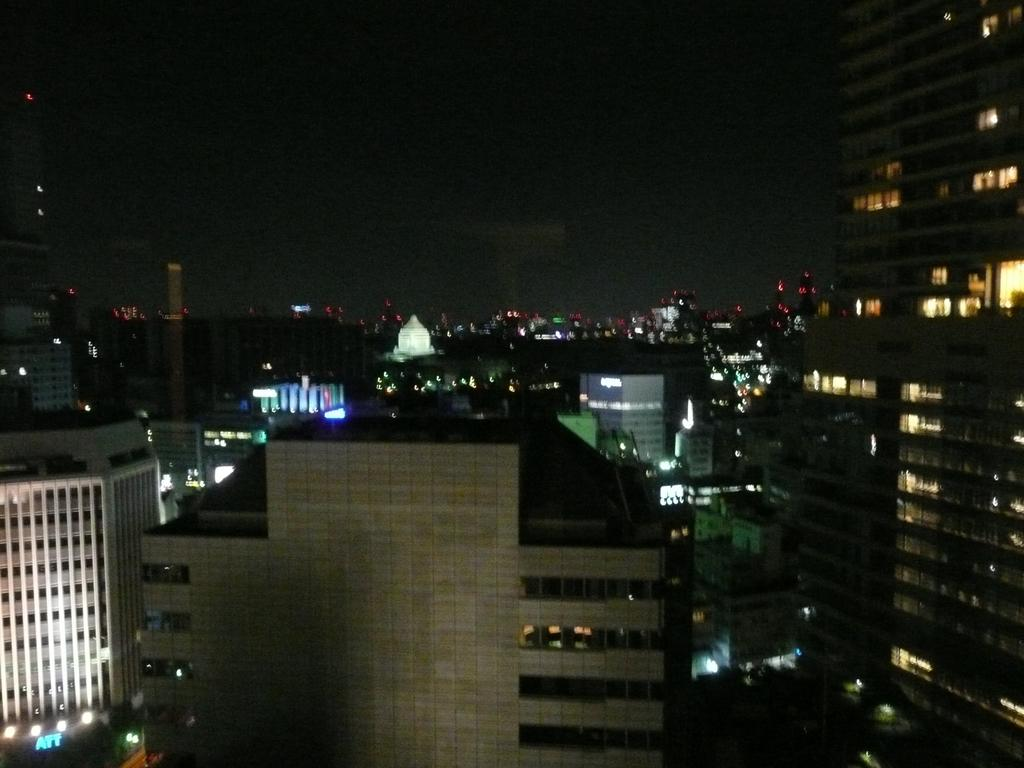What type of view is shown in the image? The image is an aerial view of a city. What structures can be seen in the image? There are buildings visible in the image. What else can be seen in the image besides buildings? There are lights visible in the image. How would you describe the sky in the image? The sky is dark in the image. What type of muscle is visible in the image? There is no muscle visible in the image; it is an aerial view of a city with buildings, lights, and a dark sky. Can you tell me how many glasses of eggnog are present in the image? There is no eggnog or glasses present in the image. 